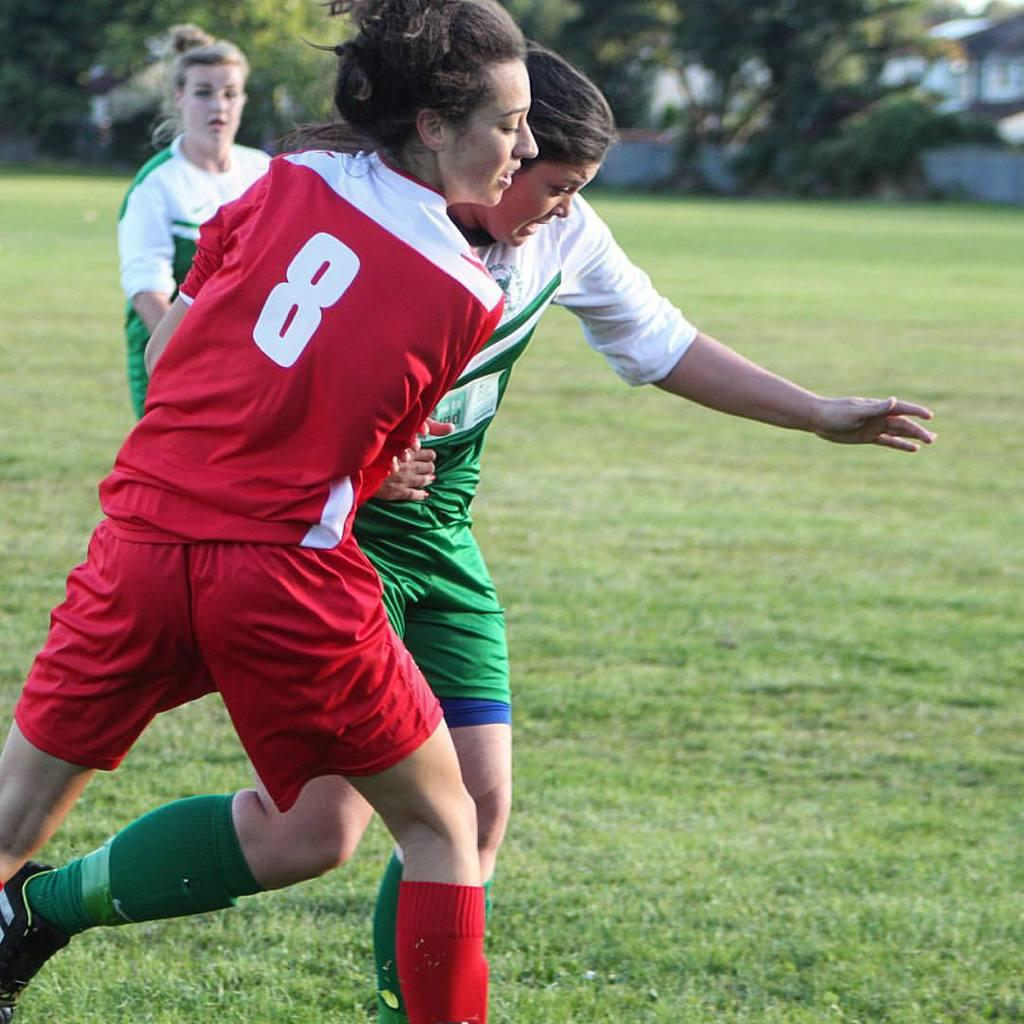<image>
Offer a succinct explanation of the picture presented. Three girls playing soccer and the one in red is number eight. 